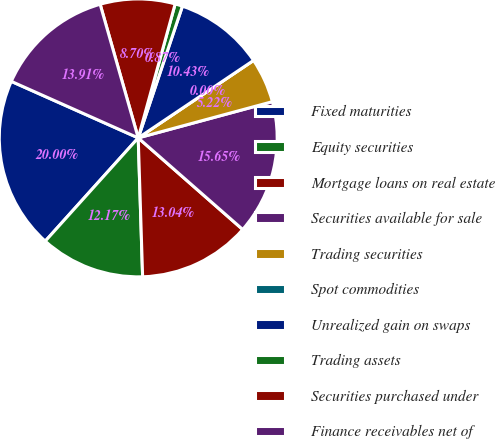Convert chart to OTSL. <chart><loc_0><loc_0><loc_500><loc_500><pie_chart><fcel>Fixed maturities<fcel>Equity securities<fcel>Mortgage loans on real estate<fcel>Securities available for sale<fcel>Trading securities<fcel>Spot commodities<fcel>Unrealized gain on swaps<fcel>Trading assets<fcel>Securities purchased under<fcel>Finance receivables net of<nl><fcel>20.0%<fcel>12.17%<fcel>13.04%<fcel>15.65%<fcel>5.22%<fcel>0.0%<fcel>10.43%<fcel>0.87%<fcel>8.7%<fcel>13.91%<nl></chart> 